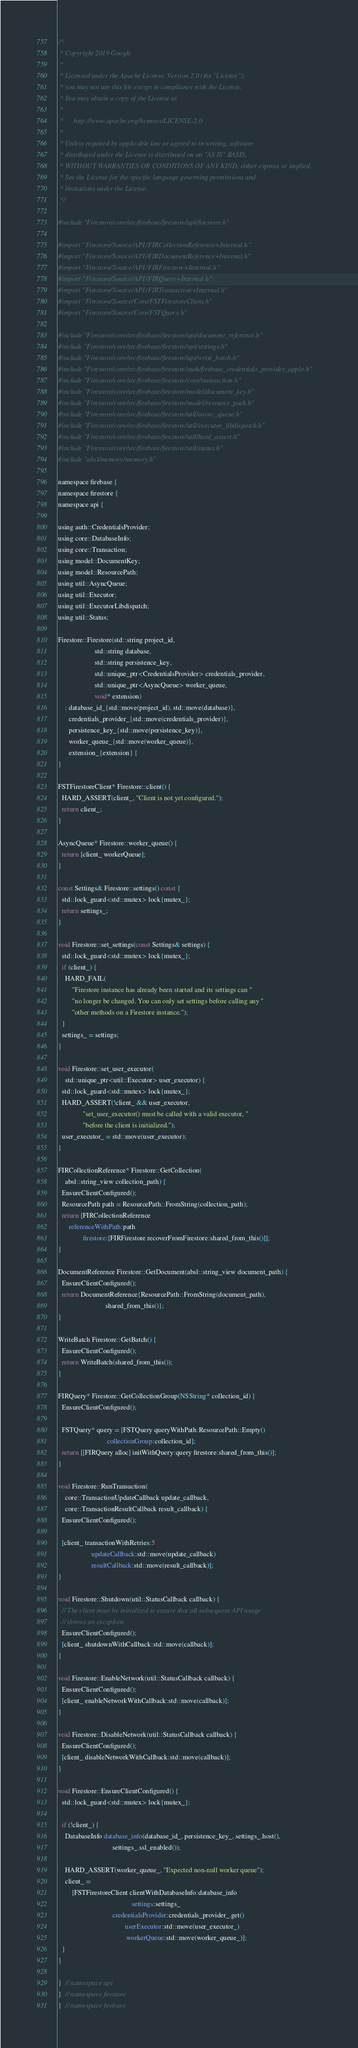Convert code to text. <code><loc_0><loc_0><loc_500><loc_500><_ObjectiveC_>/*
 * Copyright 2019 Google
 *
 * Licensed under the Apache License, Version 2.0 (the "License");
 * you may not use this file except in compliance with the License.
 * You may obtain a copy of the License at
 *
 *      http://www.apache.org/licenses/LICENSE-2.0
 *
 * Unless required by applicable law or agreed to in writing, software
 * distributed under the License is distributed on an "AS IS" BASIS,
 * WITHOUT WARRANTIES OR CONDITIONS OF ANY KIND, either express or implied.
 * See the License for the specific language governing permissions and
 * limitations under the License.
 */

#include "Firestore/core/src/firebase/firestore/api/firestore.h"

#import "Firestore/Source/API/FIRCollectionReference+Internal.h"
#import "Firestore/Source/API/FIRDocumentReference+Internal.h"
#import "Firestore/Source/API/FIRFirestore+Internal.h"
#import "Firestore/Source/API/FIRQuery+Internal.h"
#import "Firestore/Source/API/FIRTransaction+Internal.h"
#import "Firestore/Source/Core/FSTFirestoreClient.h"
#import "Firestore/Source/Core/FSTQuery.h"

#include "Firestore/core/src/firebase/firestore/api/document_reference.h"
#include "Firestore/core/src/firebase/firestore/api/settings.h"
#include "Firestore/core/src/firebase/firestore/api/write_batch.h"
#include "Firestore/core/src/firebase/firestore/auth/firebase_credentials_provider_apple.h"
#include "Firestore/core/src/firebase/firestore/core/transaction.h"
#include "Firestore/core/src/firebase/firestore/model/document_key.h"
#include "Firestore/core/src/firebase/firestore/model/resource_path.h"
#include "Firestore/core/src/firebase/firestore/util/async_queue.h"
#include "Firestore/core/src/firebase/firestore/util/executor_libdispatch.h"
#include "Firestore/core/src/firebase/firestore/util/hard_assert.h"
#include "Firestore/core/src/firebase/firestore/util/status.h"
#include "absl/memory/memory.h"

namespace firebase {
namespace firestore {
namespace api {

using auth::CredentialsProvider;
using core::DatabaseInfo;
using core::Transaction;
using model::DocumentKey;
using model::ResourcePath;
using util::AsyncQueue;
using util::Executor;
using util::ExecutorLibdispatch;
using util::Status;

Firestore::Firestore(std::string project_id,
                     std::string database,
                     std::string persistence_key,
                     std::unique_ptr<CredentialsProvider> credentials_provider,
                     std::unique_ptr<AsyncQueue> worker_queue,
                     void* extension)
    : database_id_{std::move(project_id), std::move(database)},
      credentials_provider_{std::move(credentials_provider)},
      persistence_key_{std::move(persistence_key)},
      worker_queue_{std::move(worker_queue)},
      extension_{extension} {
}

FSTFirestoreClient* Firestore::client() {
  HARD_ASSERT(client_, "Client is not yet configured.");
  return client_;
}

AsyncQueue* Firestore::worker_queue() {
  return [client_ workerQueue];
}

const Settings& Firestore::settings() const {
  std::lock_guard<std::mutex> lock{mutex_};
  return settings_;
}

void Firestore::set_settings(const Settings& settings) {
  std::lock_guard<std::mutex> lock{mutex_};
  if (client_) {
    HARD_FAIL(
        "Firestore instance has already been started and its settings can "
        "no longer be changed. You can only set settings before calling any "
        "other methods on a Firestore instance.");
  }
  settings_ = settings;
}

void Firestore::set_user_executor(
    std::unique_ptr<util::Executor> user_executor) {
  std::lock_guard<std::mutex> lock{mutex_};
  HARD_ASSERT(!client_ && user_executor,
              "set_user_executor() must be called with a valid executor, "
              "before the client is initialized.");
  user_executor_ = std::move(user_executor);
}

FIRCollectionReference* Firestore::GetCollection(
    absl::string_view collection_path) {
  EnsureClientConfigured();
  ResourcePath path = ResourcePath::FromString(collection_path);
  return [FIRCollectionReference
      referenceWithPath:path
              firestore:[FIRFirestore recoverFromFirestore:shared_from_this()]];
}

DocumentReference Firestore::GetDocument(absl::string_view document_path) {
  EnsureClientConfigured();
  return DocumentReference{ResourcePath::FromString(document_path),
                           shared_from_this()};
}

WriteBatch Firestore::GetBatch() {
  EnsureClientConfigured();
  return WriteBatch(shared_from_this());
}

FIRQuery* Firestore::GetCollectionGroup(NSString* collection_id) {
  EnsureClientConfigured();

  FSTQuery* query = [FSTQuery queryWithPath:ResourcePath::Empty()
                            collectionGroup:collection_id];
  return [[FIRQuery alloc] initWithQuery:query firestore:shared_from_this()];
}

void Firestore::RunTransaction(
    core::TransactionUpdateCallback update_callback,
    core::TransactionResultCallback result_callback) {
  EnsureClientConfigured();

  [client_ transactionWithRetries:5
                   updateCallback:std::move(update_callback)
                   resultCallback:std::move(result_callback)];
}

void Firestore::Shutdown(util::StatusCallback callback) {
  // The client must be initialized to ensure that all subsequent API usage
  // throws an exception.
  EnsureClientConfigured();
  [client_ shutdownWithCallback:std::move(callback)];
}

void Firestore::EnableNetwork(util::StatusCallback callback) {
  EnsureClientConfigured();
  [client_ enableNetworkWithCallback:std::move(callback)];
}

void Firestore::DisableNetwork(util::StatusCallback callback) {
  EnsureClientConfigured();
  [client_ disableNetworkWithCallback:std::move(callback)];
}

void Firestore::EnsureClientConfigured() {
  std::lock_guard<std::mutex> lock{mutex_};

  if (!client_) {
    DatabaseInfo database_info(database_id_, persistence_key_, settings_.host(),
                               settings_.ssl_enabled());

    HARD_ASSERT(worker_queue_, "Expected non-null worker queue");
    client_ =
        [FSTFirestoreClient clientWithDatabaseInfo:database_info
                                          settings:settings_
                               credentialsProvider:credentials_provider_.get()
                                      userExecutor:std::move(user_executor_)
                                       workerQueue:std::move(worker_queue_)];
  }
}

}  // namespace api
}  // namespace firestore
}  // namespace firebase
</code> 